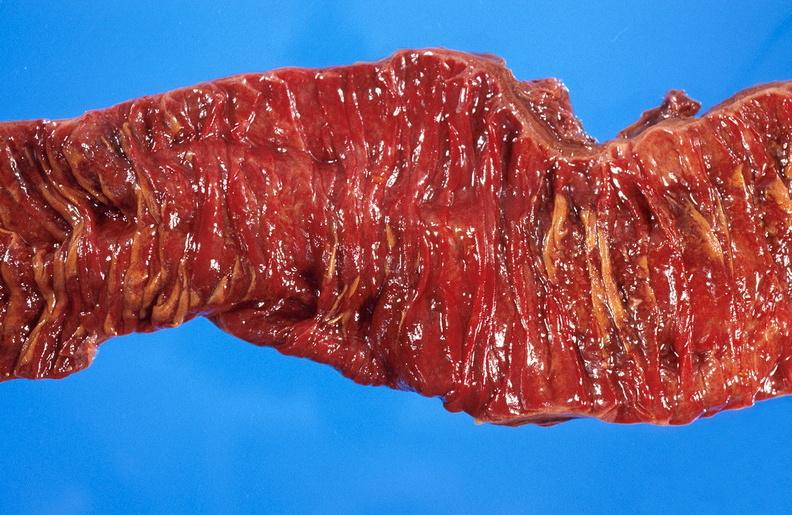does myocardium show ischemic bowel?
Answer the question using a single word or phrase. No 